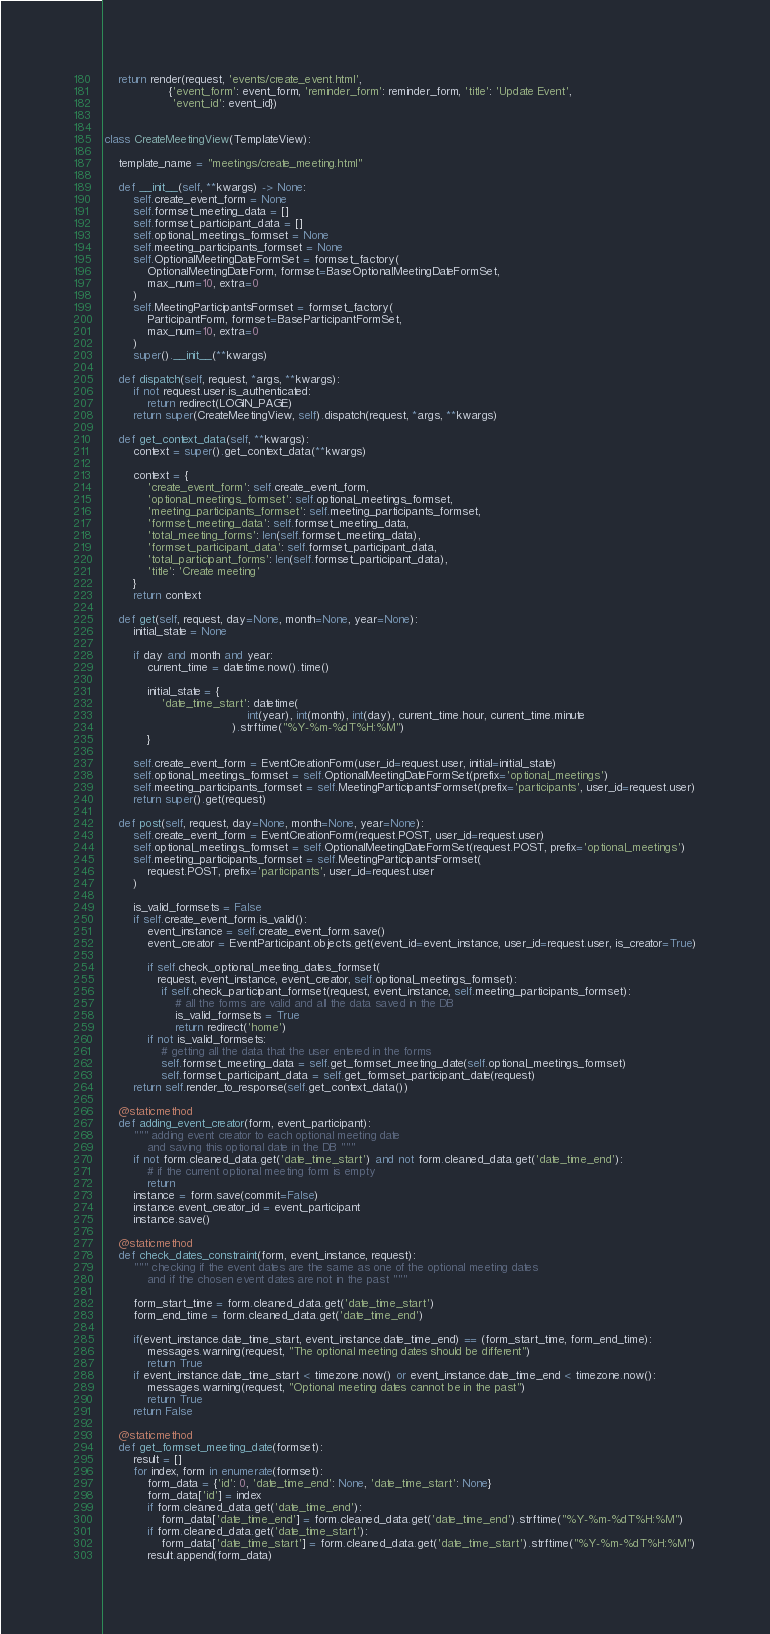Convert code to text. <code><loc_0><loc_0><loc_500><loc_500><_Python_>    return render(request, 'events/create_event.html',
                  {'event_form': event_form, 'reminder_form': reminder_form, 'title': 'Update Event',
                   'event_id': event_id})


class CreateMeetingView(TemplateView):

    template_name = "meetings/create_meeting.html"

    def __init__(self, **kwargs) -> None:
        self.create_event_form = None
        self.formset_meeting_data = []
        self.formset_participant_data = []
        self.optional_meetings_formset = None
        self.meeting_participants_formset = None
        self.OptionalMeetingDateFormSet = formset_factory(
            OptionalMeetingDateForm, formset=BaseOptionalMeetingDateFormSet,
            max_num=10, extra=0
        )
        self.MeetingParticipantsFormset = formset_factory(
            ParticipantForm, formset=BaseParticipantFormSet,
            max_num=10, extra=0
        )
        super().__init__(**kwargs)

    def dispatch(self, request, *args, **kwargs):
        if not request.user.is_authenticated:
            return redirect(LOGIN_PAGE)
        return super(CreateMeetingView, self).dispatch(request, *args, **kwargs)

    def get_context_data(self, **kwargs):
        context = super().get_context_data(**kwargs)

        context = {
            'create_event_form': self.create_event_form,
            'optional_meetings_formset': self.optional_meetings_formset,
            'meeting_participants_formset': self.meeting_participants_formset,
            'formset_meeting_data': self.formset_meeting_data,
            'total_meeting_forms': len(self.formset_meeting_data),
            'formset_participant_data': self.formset_participant_data,
            'total_participant_forms': len(self.formset_participant_data),
            'title': 'Create meeting'
        }
        return context

    def get(self, request, day=None, month=None, year=None):
        initial_state = None

        if day and month and year:
            current_time = datetime.now().time()

            initial_state = {
                'date_time_start': datetime(
                                        int(year), int(month), int(day), current_time.hour, current_time.minute
                                    ).strftime("%Y-%m-%dT%H:%M")
            }

        self.create_event_form = EventCreationForm(user_id=request.user, initial=initial_state)
        self.optional_meetings_formset = self.OptionalMeetingDateFormSet(prefix='optional_meetings')
        self.meeting_participants_formset = self.MeetingParticipantsFormset(prefix='participants', user_id=request.user)
        return super().get(request)

    def post(self, request, day=None, month=None, year=None):
        self.create_event_form = EventCreationForm(request.POST, user_id=request.user)
        self.optional_meetings_formset = self.OptionalMeetingDateFormSet(request.POST, prefix='optional_meetings')
        self.meeting_participants_formset = self.MeetingParticipantsFormset(
            request.POST, prefix='participants', user_id=request.user
        )

        is_valid_formsets = False
        if self.create_event_form.is_valid():
            event_instance = self.create_event_form.save()
            event_creator = EventParticipant.objects.get(event_id=event_instance, user_id=request.user, is_creator=True)

            if self.check_optional_meeting_dates_formset(
               request, event_instance, event_creator, self.optional_meetings_formset):
                if self.check_participant_formset(request, event_instance, self.meeting_participants_formset):
                    # all the forms are valid and all the data saved in the DB
                    is_valid_formsets = True
                    return redirect('home')
            if not is_valid_formsets:
                # getting all the data that the user entered in the forms
                self.formset_meeting_data = self.get_formset_meeting_date(self.optional_meetings_formset)
                self.formset_participant_data = self.get_formset_participant_date(request)
        return self.render_to_response(self.get_context_data())

    @staticmethod
    def adding_event_creator(form, event_participant):
        """ adding event creator to each optional meeting date
            and saving this optional date in the DB """
        if not form.cleaned_data.get('date_time_start') and not form.cleaned_data.get('date_time_end'):
            # if the current optional meeting form is empty
            return
        instance = form.save(commit=False)
        instance.event_creator_id = event_participant
        instance.save()

    @staticmethod
    def check_dates_constraint(form, event_instance, request):
        """ checking if the event dates are the same as one of the optional meeting dates
            and if the chosen event dates are not in the past """

        form_start_time = form.cleaned_data.get('date_time_start')
        form_end_time = form.cleaned_data.get('date_time_end')

        if(event_instance.date_time_start, event_instance.date_time_end) == (form_start_time, form_end_time):
            messages.warning(request, "The optional meeting dates should be different")
            return True
        if event_instance.date_time_start < timezone.now() or event_instance.date_time_end < timezone.now():
            messages.warning(request, "Optional meeting dates cannot be in the past")
            return True
        return False

    @staticmethod
    def get_formset_meeting_date(formset):
        result = []
        for index, form in enumerate(formset):
            form_data = {'id': 0, 'date_time_end': None, 'date_time_start': None}
            form_data['id'] = index
            if form.cleaned_data.get('date_time_end'):
                form_data['date_time_end'] = form.cleaned_data.get('date_time_end').strftime("%Y-%m-%dT%H:%M")
            if form.cleaned_data.get('date_time_start'):
                form_data['date_time_start'] = form.cleaned_data.get('date_time_start').strftime("%Y-%m-%dT%H:%M")
            result.append(form_data)</code> 